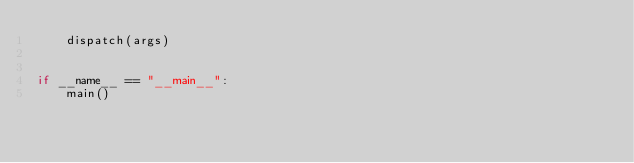<code> <loc_0><loc_0><loc_500><loc_500><_Python_>    dispatch(args)


if __name__ == "__main__":
    main()
</code> 